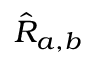Convert formula to latex. <formula><loc_0><loc_0><loc_500><loc_500>\hat { R } _ { a , b }</formula> 